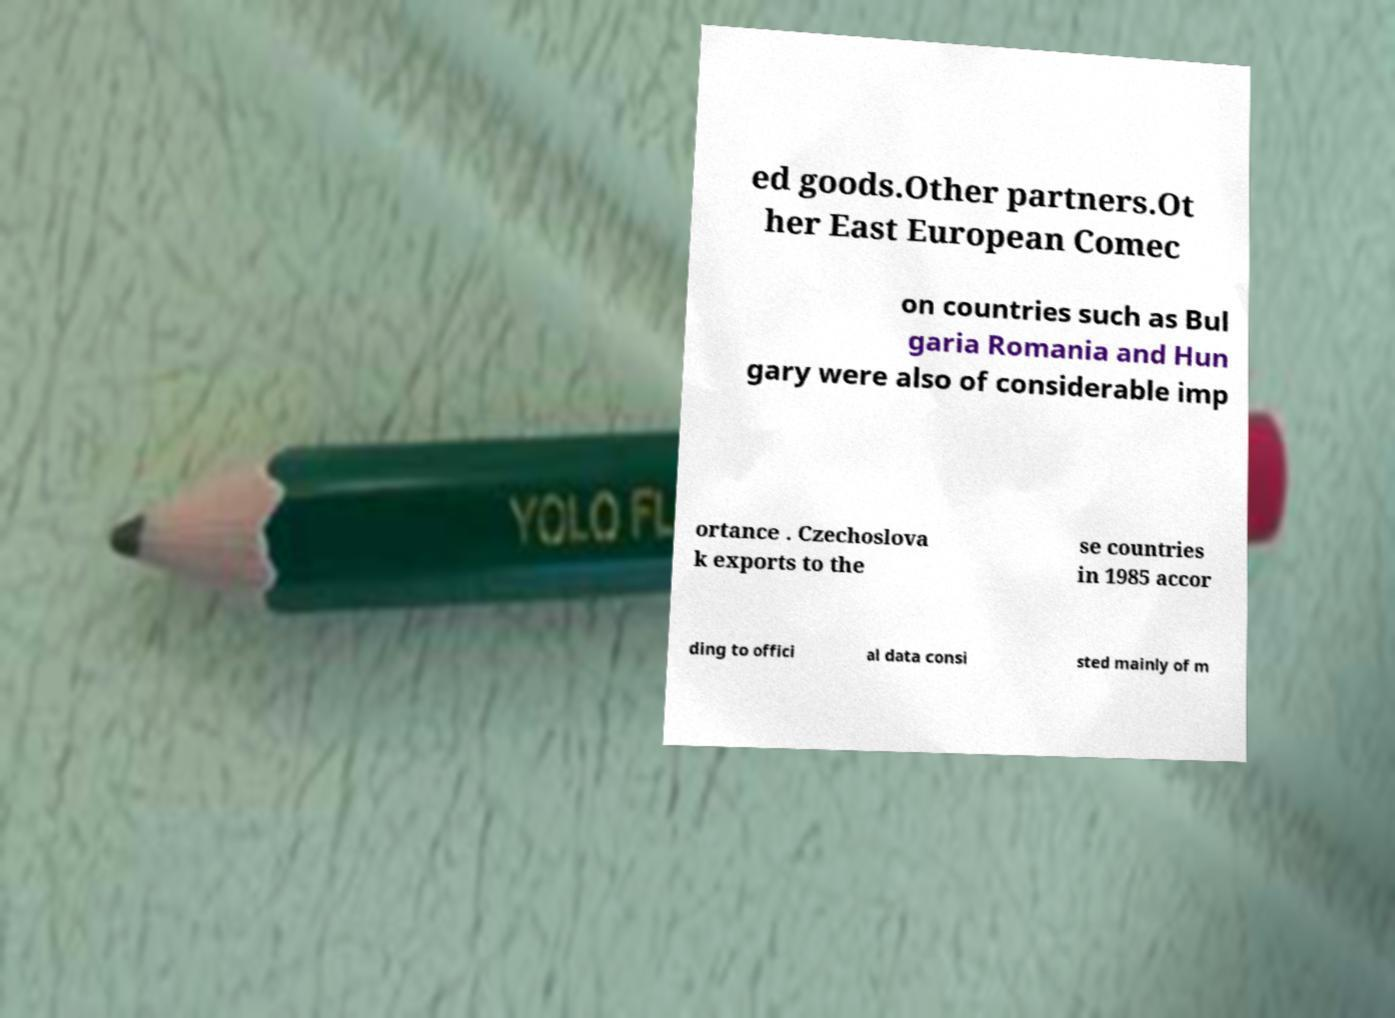Could you assist in decoding the text presented in this image and type it out clearly? ed goods.Other partners.Ot her East European Comec on countries such as Bul garia Romania and Hun gary were also of considerable imp ortance . Czechoslova k exports to the se countries in 1985 accor ding to offici al data consi sted mainly of m 